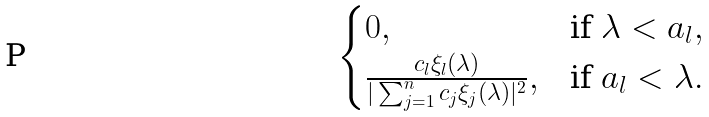<formula> <loc_0><loc_0><loc_500><loc_500>\begin{cases} 0 , & \text {if } \lambda < a _ { l } , \\ \frac { c _ { l } \xi _ { l } ( \lambda ) } { | \sum _ { j = 1 } ^ { n } c _ { j } \xi _ { j } ( \lambda ) | ^ { 2 } } , & \text {if } a _ { l } < \lambda . \end{cases}</formula> 